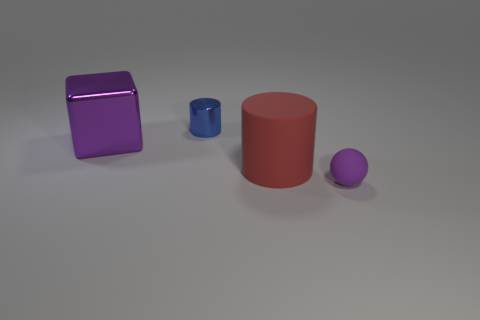Add 2 large cylinders. How many objects exist? 6 Subtract all spheres. How many objects are left? 3 Subtract 0 green cubes. How many objects are left? 4 Subtract all blue shiny cylinders. Subtract all small purple matte cylinders. How many objects are left? 3 Add 2 tiny shiny cylinders. How many tiny shiny cylinders are left? 3 Add 2 yellow cubes. How many yellow cubes exist? 2 